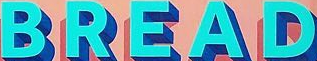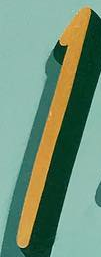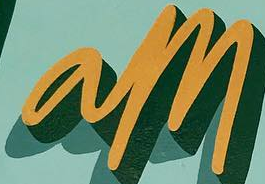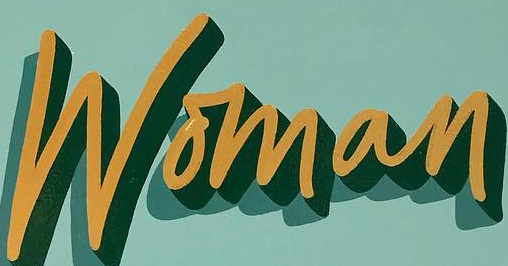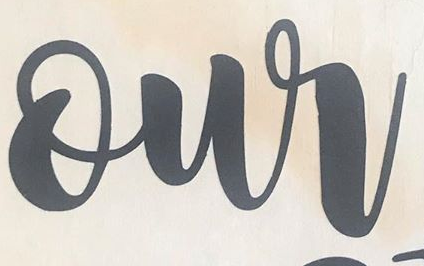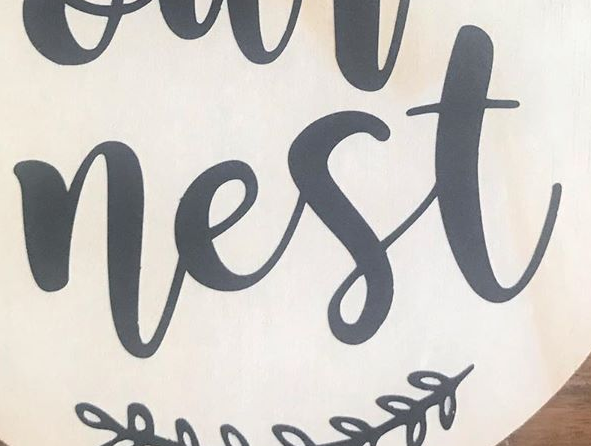What words can you see in these images in sequence, separated by a semicolon? BREAD; I; am; Woman; our; nest 